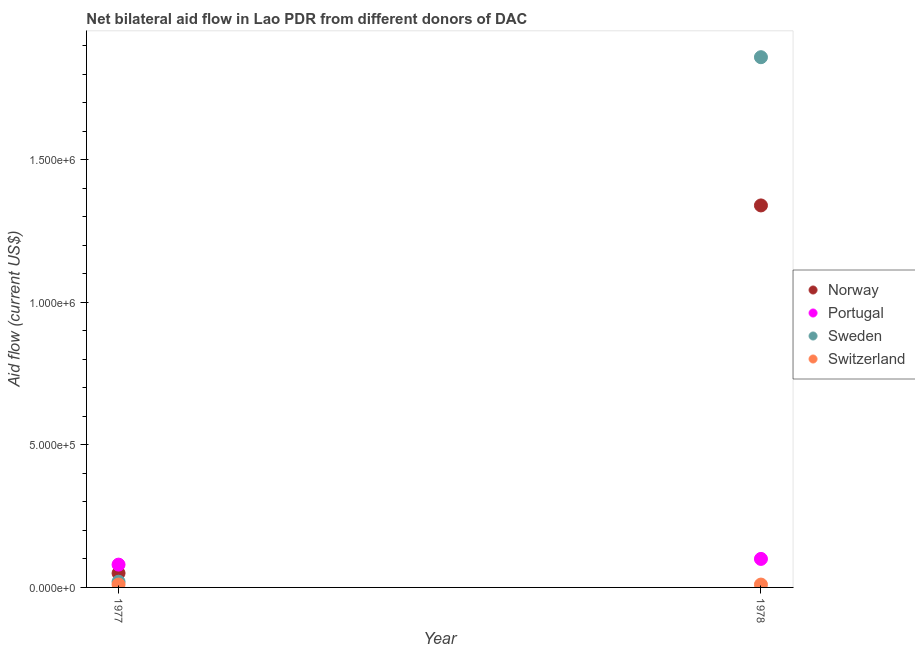How many different coloured dotlines are there?
Make the answer very short. 4. What is the amount of aid given by switzerland in 1978?
Your answer should be very brief. 10000. Across all years, what is the maximum amount of aid given by portugal?
Offer a very short reply. 1.00e+05. Across all years, what is the minimum amount of aid given by norway?
Provide a short and direct response. 5.00e+04. In which year was the amount of aid given by sweden maximum?
Your response must be concise. 1978. What is the total amount of aid given by switzerland in the graph?
Ensure brevity in your answer.  2.00e+04. What is the difference between the amount of aid given by sweden in 1977 and that in 1978?
Offer a very short reply. -1.84e+06. What is the difference between the amount of aid given by norway in 1978 and the amount of aid given by portugal in 1977?
Provide a short and direct response. 1.26e+06. In the year 1978, what is the difference between the amount of aid given by sweden and amount of aid given by norway?
Offer a very short reply. 5.20e+05. What is the ratio of the amount of aid given by sweden in 1977 to that in 1978?
Your answer should be compact. 0.01. Is the amount of aid given by norway in 1977 less than that in 1978?
Offer a terse response. Yes. In how many years, is the amount of aid given by portugal greater than the average amount of aid given by portugal taken over all years?
Give a very brief answer. 1. Is it the case that in every year, the sum of the amount of aid given by switzerland and amount of aid given by norway is greater than the sum of amount of aid given by sweden and amount of aid given by portugal?
Keep it short and to the point. No. Is it the case that in every year, the sum of the amount of aid given by norway and amount of aid given by portugal is greater than the amount of aid given by sweden?
Your answer should be compact. No. Is the amount of aid given by norway strictly less than the amount of aid given by portugal over the years?
Your answer should be compact. No. How many years are there in the graph?
Make the answer very short. 2. What is the difference between two consecutive major ticks on the Y-axis?
Make the answer very short. 5.00e+05. Are the values on the major ticks of Y-axis written in scientific E-notation?
Offer a terse response. Yes. Does the graph contain any zero values?
Ensure brevity in your answer.  No. Where does the legend appear in the graph?
Your response must be concise. Center right. How are the legend labels stacked?
Give a very brief answer. Vertical. What is the title of the graph?
Ensure brevity in your answer.  Net bilateral aid flow in Lao PDR from different donors of DAC. Does "WFP" appear as one of the legend labels in the graph?
Give a very brief answer. No. What is the label or title of the Y-axis?
Ensure brevity in your answer.  Aid flow (current US$). What is the Aid flow (current US$) in Norway in 1977?
Offer a terse response. 5.00e+04. What is the Aid flow (current US$) of Sweden in 1977?
Provide a short and direct response. 2.00e+04. What is the Aid flow (current US$) of Norway in 1978?
Offer a very short reply. 1.34e+06. What is the Aid flow (current US$) of Sweden in 1978?
Keep it short and to the point. 1.86e+06. Across all years, what is the maximum Aid flow (current US$) in Norway?
Offer a very short reply. 1.34e+06. Across all years, what is the maximum Aid flow (current US$) in Sweden?
Make the answer very short. 1.86e+06. Across all years, what is the maximum Aid flow (current US$) of Switzerland?
Offer a very short reply. 10000. Across all years, what is the minimum Aid flow (current US$) of Norway?
Provide a short and direct response. 5.00e+04. What is the total Aid flow (current US$) in Norway in the graph?
Offer a very short reply. 1.39e+06. What is the total Aid flow (current US$) in Portugal in the graph?
Give a very brief answer. 1.80e+05. What is the total Aid flow (current US$) in Sweden in the graph?
Offer a very short reply. 1.88e+06. What is the difference between the Aid flow (current US$) of Norway in 1977 and that in 1978?
Keep it short and to the point. -1.29e+06. What is the difference between the Aid flow (current US$) of Portugal in 1977 and that in 1978?
Keep it short and to the point. -2.00e+04. What is the difference between the Aid flow (current US$) of Sweden in 1977 and that in 1978?
Make the answer very short. -1.84e+06. What is the difference between the Aid flow (current US$) in Switzerland in 1977 and that in 1978?
Your answer should be compact. 0. What is the difference between the Aid flow (current US$) in Norway in 1977 and the Aid flow (current US$) in Portugal in 1978?
Your answer should be very brief. -5.00e+04. What is the difference between the Aid flow (current US$) in Norway in 1977 and the Aid flow (current US$) in Sweden in 1978?
Offer a terse response. -1.81e+06. What is the difference between the Aid flow (current US$) of Portugal in 1977 and the Aid flow (current US$) of Sweden in 1978?
Keep it short and to the point. -1.78e+06. What is the difference between the Aid flow (current US$) of Portugal in 1977 and the Aid flow (current US$) of Switzerland in 1978?
Give a very brief answer. 7.00e+04. What is the difference between the Aid flow (current US$) in Sweden in 1977 and the Aid flow (current US$) in Switzerland in 1978?
Ensure brevity in your answer.  10000. What is the average Aid flow (current US$) of Norway per year?
Give a very brief answer. 6.95e+05. What is the average Aid flow (current US$) in Portugal per year?
Offer a terse response. 9.00e+04. What is the average Aid flow (current US$) of Sweden per year?
Your answer should be compact. 9.40e+05. What is the average Aid flow (current US$) of Switzerland per year?
Provide a succinct answer. 10000. In the year 1977, what is the difference between the Aid flow (current US$) of Norway and Aid flow (current US$) of Sweden?
Your answer should be very brief. 3.00e+04. In the year 1977, what is the difference between the Aid flow (current US$) of Norway and Aid flow (current US$) of Switzerland?
Your response must be concise. 4.00e+04. In the year 1977, what is the difference between the Aid flow (current US$) of Portugal and Aid flow (current US$) of Sweden?
Your answer should be very brief. 6.00e+04. In the year 1977, what is the difference between the Aid flow (current US$) in Portugal and Aid flow (current US$) in Switzerland?
Give a very brief answer. 7.00e+04. In the year 1978, what is the difference between the Aid flow (current US$) of Norway and Aid flow (current US$) of Portugal?
Ensure brevity in your answer.  1.24e+06. In the year 1978, what is the difference between the Aid flow (current US$) in Norway and Aid flow (current US$) in Sweden?
Your response must be concise. -5.20e+05. In the year 1978, what is the difference between the Aid flow (current US$) of Norway and Aid flow (current US$) of Switzerland?
Make the answer very short. 1.33e+06. In the year 1978, what is the difference between the Aid flow (current US$) in Portugal and Aid flow (current US$) in Sweden?
Your response must be concise. -1.76e+06. In the year 1978, what is the difference between the Aid flow (current US$) of Portugal and Aid flow (current US$) of Switzerland?
Your answer should be very brief. 9.00e+04. In the year 1978, what is the difference between the Aid flow (current US$) in Sweden and Aid flow (current US$) in Switzerland?
Keep it short and to the point. 1.85e+06. What is the ratio of the Aid flow (current US$) of Norway in 1977 to that in 1978?
Provide a short and direct response. 0.04. What is the ratio of the Aid flow (current US$) of Sweden in 1977 to that in 1978?
Make the answer very short. 0.01. What is the difference between the highest and the second highest Aid flow (current US$) of Norway?
Make the answer very short. 1.29e+06. What is the difference between the highest and the second highest Aid flow (current US$) of Portugal?
Your response must be concise. 2.00e+04. What is the difference between the highest and the second highest Aid flow (current US$) in Sweden?
Offer a very short reply. 1.84e+06. What is the difference between the highest and the second highest Aid flow (current US$) in Switzerland?
Give a very brief answer. 0. What is the difference between the highest and the lowest Aid flow (current US$) in Norway?
Your answer should be very brief. 1.29e+06. What is the difference between the highest and the lowest Aid flow (current US$) in Portugal?
Make the answer very short. 2.00e+04. What is the difference between the highest and the lowest Aid flow (current US$) in Sweden?
Offer a very short reply. 1.84e+06. What is the difference between the highest and the lowest Aid flow (current US$) in Switzerland?
Provide a short and direct response. 0. 